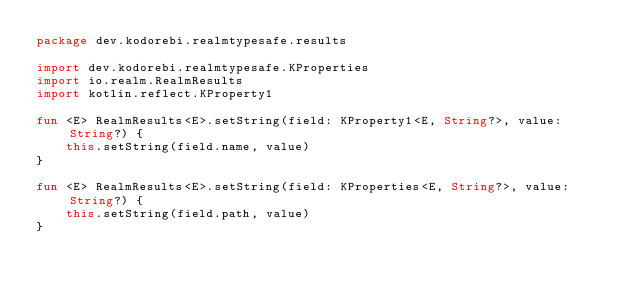Convert code to text. <code><loc_0><loc_0><loc_500><loc_500><_Kotlin_>package dev.kodorebi.realmtypesafe.results

import dev.kodorebi.realmtypesafe.KProperties
import io.realm.RealmResults
import kotlin.reflect.KProperty1

fun <E> RealmResults<E>.setString(field: KProperty1<E, String?>, value: String?) {
    this.setString(field.name, value)
}

fun <E> RealmResults<E>.setString(field: KProperties<E, String?>, value: String?) {
    this.setString(field.path, value)
}</code> 